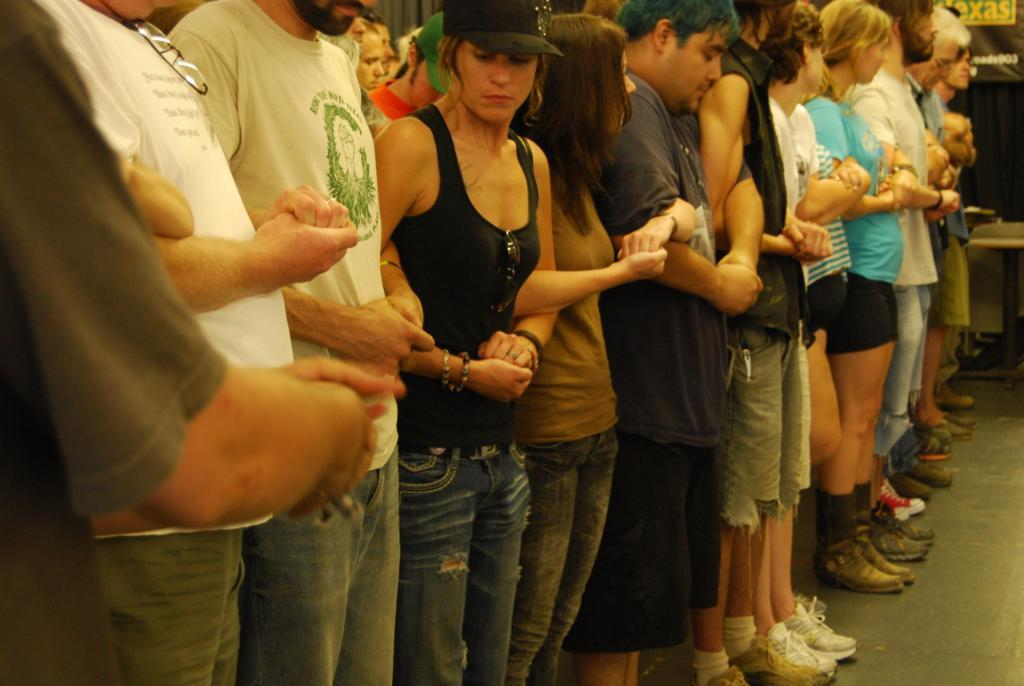What is happening in the image involving the people? The people in the image are standing and holding hands with each other. Can you describe the floor in the image? The floor is visible in the image. What time of day is it in the image, as indicated by the presence of an afternoon hose? There is no hose present in the image, and the time of day cannot be determined from the image alone. 